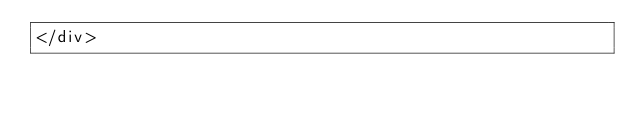<code> <loc_0><loc_0><loc_500><loc_500><_PHP_></div>
</code> 